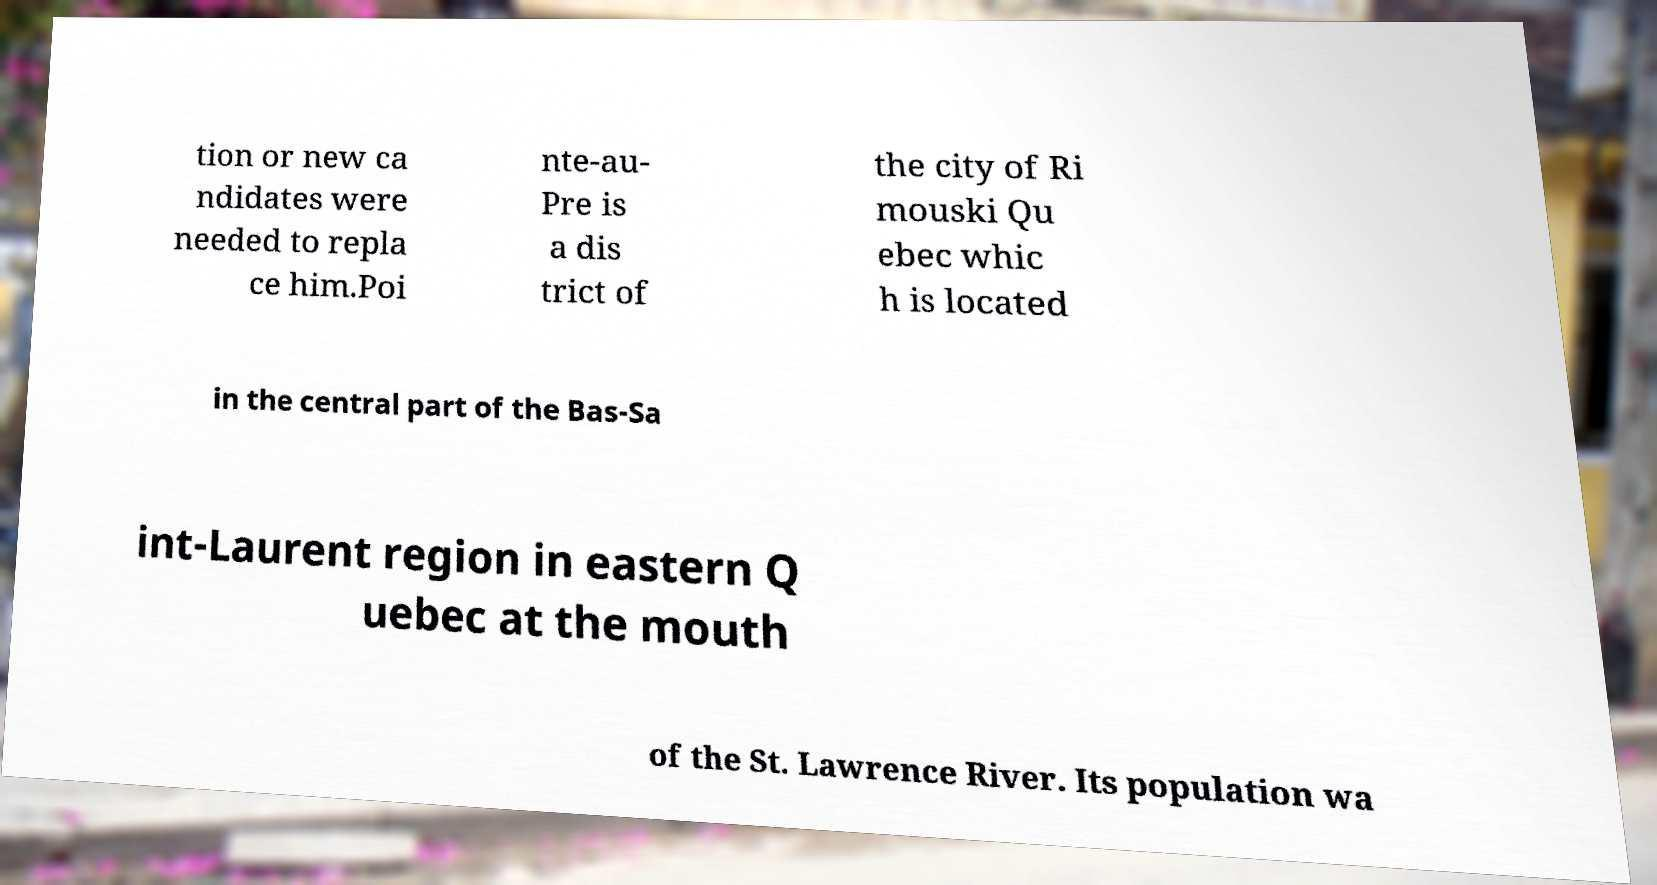Could you extract and type out the text from this image? tion or new ca ndidates were needed to repla ce him.Poi nte-au- Pre is a dis trict of the city of Ri mouski Qu ebec whic h is located in the central part of the Bas-Sa int-Laurent region in eastern Q uebec at the mouth of the St. Lawrence River. Its population wa 